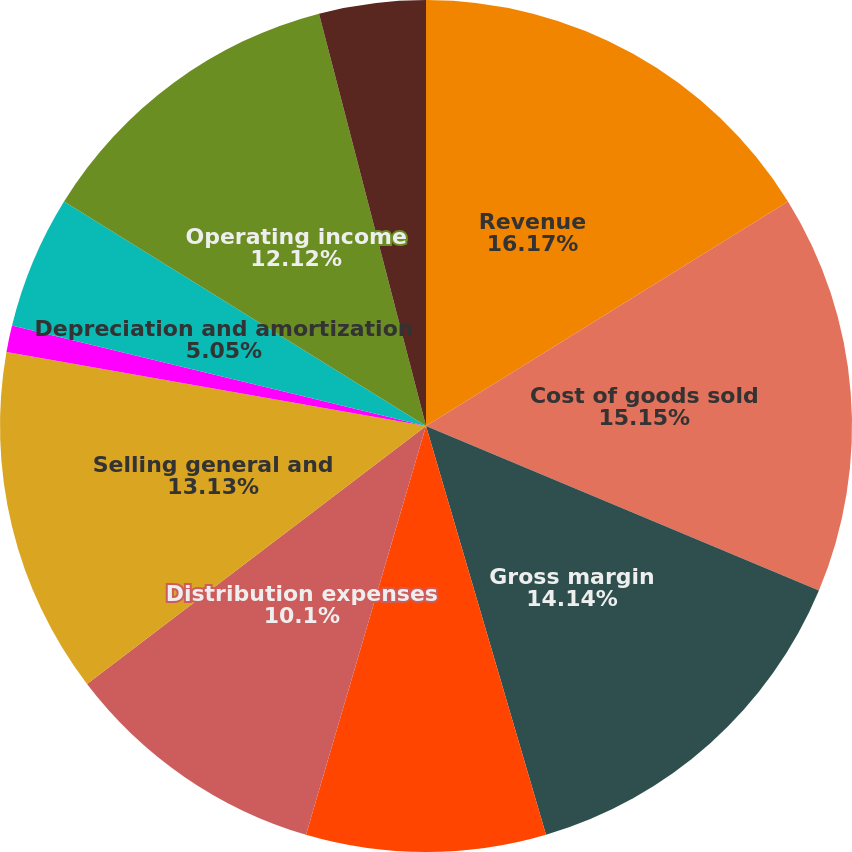Convert chart to OTSL. <chart><loc_0><loc_0><loc_500><loc_500><pie_chart><fcel>Revenue<fcel>Cost of goods sold<fcel>Gross margin<fcel>Facility and warehouse<fcel>Distribution expenses<fcel>Selling general and<fcel>Restructuring and acquisition<fcel>Depreciation and amortization<fcel>Operating income<fcel>Interest expense<nl><fcel>16.16%<fcel>15.15%<fcel>14.14%<fcel>9.09%<fcel>10.1%<fcel>13.13%<fcel>1.01%<fcel>5.05%<fcel>12.12%<fcel>4.04%<nl></chart> 